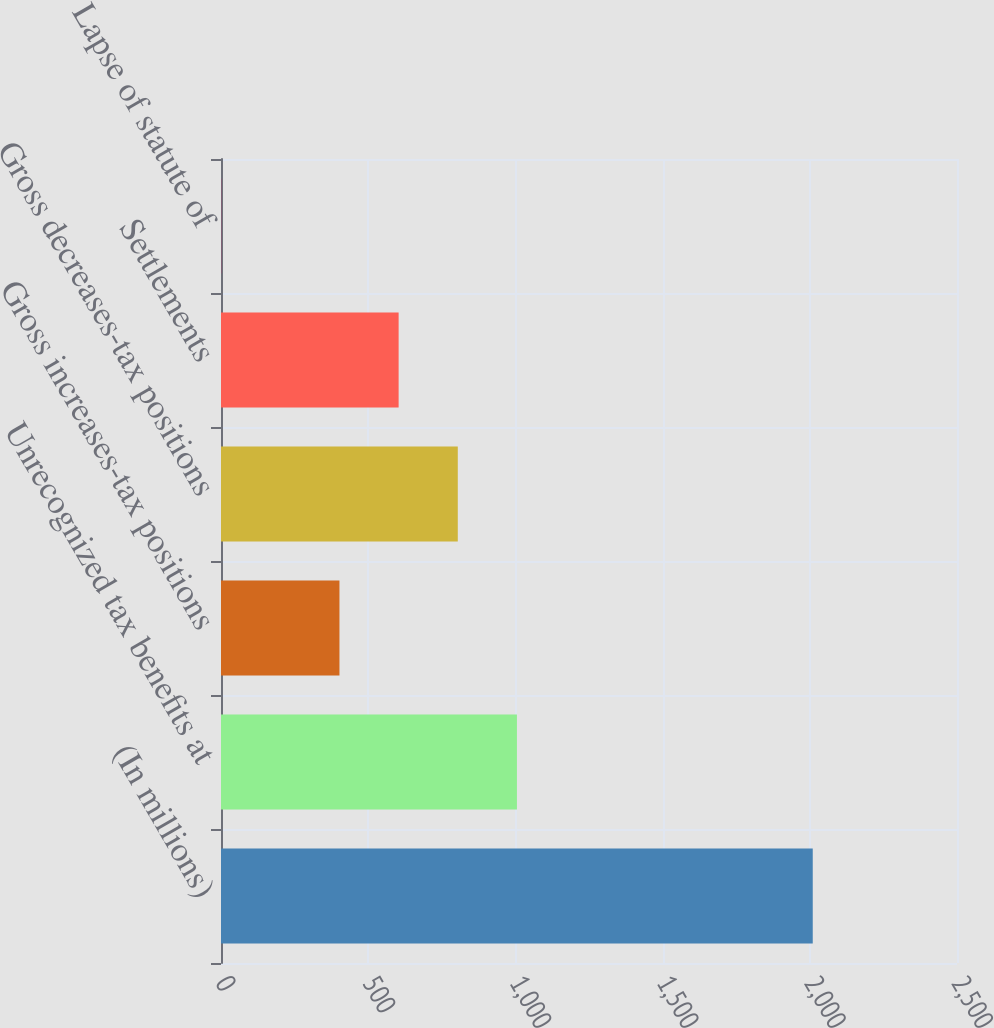<chart> <loc_0><loc_0><loc_500><loc_500><bar_chart><fcel>(In millions)<fcel>Unrecognized tax benefits at<fcel>Gross increases-tax positions<fcel>Gross decreases-tax positions<fcel>Settlements<fcel>Lapse of statute of<nl><fcel>2010<fcel>1005.25<fcel>402.4<fcel>804.3<fcel>603.35<fcel>0.5<nl></chart> 